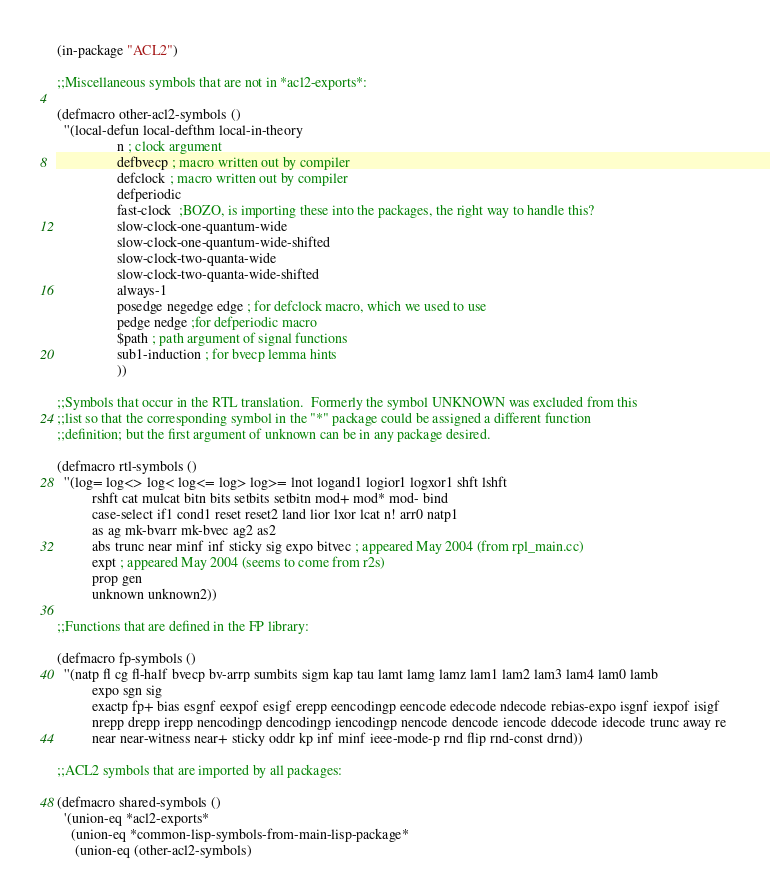<code> <loc_0><loc_0><loc_500><loc_500><_Lisp_>(in-package "ACL2")

;;Miscellaneous symbols that are not in *acl2-exports*:

(defmacro other-acl2-symbols ()
  ''(local-defun local-defthm local-in-theory
                 n ; clock argument
                 defbvecp ; macro written out by compiler
                 defclock ; macro written out by compiler
                 defperiodic
                 fast-clock  ;BOZO, is importing these into the packages, the right way to handle this?
                 slow-clock-one-quantum-wide
                 slow-clock-one-quantum-wide-shifted
                 slow-clock-two-quanta-wide
                 slow-clock-two-quanta-wide-shifted
                 always-1
                 posedge negedge edge ; for defclock macro, which we used to use
                 pedge nedge ;for defperiodic macro
                 $path ; path argument of signal functions
                 sub1-induction ; for bvecp lemma hints
                 ))

;;Symbols that occur in the RTL translation.  Formerly the symbol UNKNOWN was excluded from this
;;list so that the corresponding symbol in the "*" package could be assigned a different function
;;definition; but the first argument of unknown can be in any package desired.

(defmacro rtl-symbols ()
  ''(log= log<> log< log<= log> log>= lnot logand1 logior1 logxor1 shft lshft
          rshft cat mulcat bitn bits setbits setbitn mod+ mod* mod- bind
          case-select if1 cond1 reset reset2 land lior lxor lcat n! arr0 natp1
          as ag mk-bvarr mk-bvec ag2 as2
          abs trunc near minf inf sticky sig expo bitvec ; appeared May 2004 (from rpl_main.cc)
          expt ; appeared May 2004 (seems to come from r2s)
          prop gen
          unknown unknown2))

;;Functions that are defined in the FP library:

(defmacro fp-symbols ()
  ''(natp fl cg fl-half bvecp bv-arrp sumbits sigm kap tau lamt lamg lamz lam1 lam2 lam3 lam4 lam0 lamb
          expo sgn sig 
          exactp fp+ bias esgnf eexpof esigf erepp eencodingp eencode edecode ndecode rebias-expo isgnf iexpof isigf 
          nrepp drepp irepp nencodingp dencodingp iencodingp nencode dencode iencode ddecode idecode trunc away re 
          near near-witness near+ sticky oddr kp inf minf ieee-mode-p rnd flip rnd-const drnd))

;;ACL2 symbols that are imported by all packages:

(defmacro shared-symbols ()
  '(union-eq *acl2-exports*
    (union-eq *common-lisp-symbols-from-main-lisp-package*
     (union-eq (other-acl2-symbols)</code> 